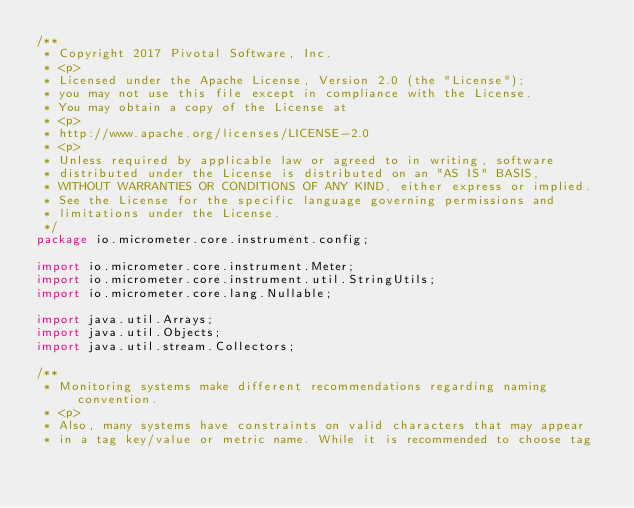Convert code to text. <code><loc_0><loc_0><loc_500><loc_500><_Java_>/**
 * Copyright 2017 Pivotal Software, Inc.
 * <p>
 * Licensed under the Apache License, Version 2.0 (the "License");
 * you may not use this file except in compliance with the License.
 * You may obtain a copy of the License at
 * <p>
 * http://www.apache.org/licenses/LICENSE-2.0
 * <p>
 * Unless required by applicable law or agreed to in writing, software
 * distributed under the License is distributed on an "AS IS" BASIS,
 * WITHOUT WARRANTIES OR CONDITIONS OF ANY KIND, either express or implied.
 * See the License for the specific language governing permissions and
 * limitations under the License.
 */
package io.micrometer.core.instrument.config;

import io.micrometer.core.instrument.Meter;
import io.micrometer.core.instrument.util.StringUtils;
import io.micrometer.core.lang.Nullable;

import java.util.Arrays;
import java.util.Objects;
import java.util.stream.Collectors;

/**
 * Monitoring systems make different recommendations regarding naming convention.
 * <p>
 * Also, many systems have constraints on valid characters that may appear
 * in a tag key/value or metric name. While it is recommended to choose tag</code> 